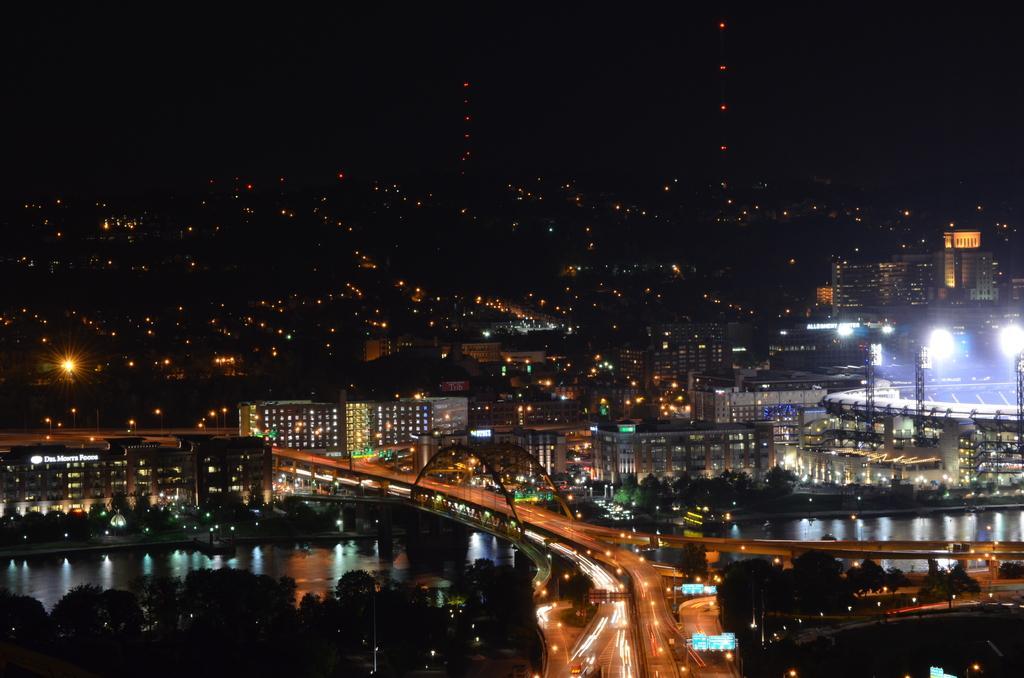In one or two sentences, can you explain what this image depicts? This image consists of a bridge on which there are vehicles moving. At the bottom, there are trees along with water. In the background, there are many buildings along with the lights. 